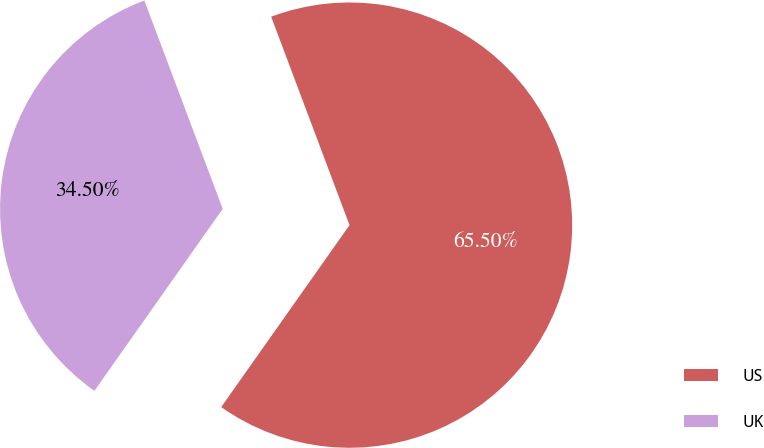Convert chart. <chart><loc_0><loc_0><loc_500><loc_500><pie_chart><fcel>US<fcel>UK<nl><fcel>65.5%<fcel>34.5%<nl></chart> 